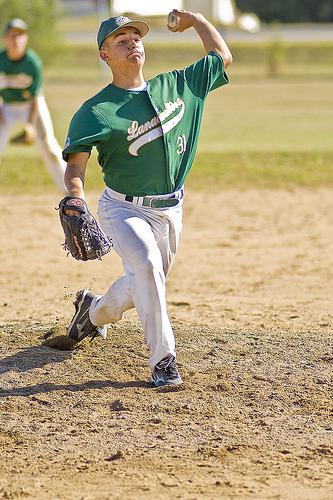Question: when was this photo taken?
Choices:
A. At night.
B. During the day.
C. At dusk.
D. At dawn.
Answer with the letter. Answer: B Question: what sport is being played?
Choices:
A. Baseball.
B. Basketball.
C. Football.
D. Soccer.
Answer with the letter. Answer: A Question: who is the person throwing the ball?
Choices:
A. Baseball player.
B. Basketball player.
C. Soccer player.
D. Tennis player.
Answer with the letter. Answer: A Question: what color uniform shirt does the player have on?
Choices:
A. Blue.
B. Green.
C. Yellow.
D. Gray.
Answer with the letter. Answer: B Question: what color pants does the person throwing the ball have on?
Choices:
A. Green.
B. White.
C. Red.
D. Blue.
Answer with the letter. Answer: B 